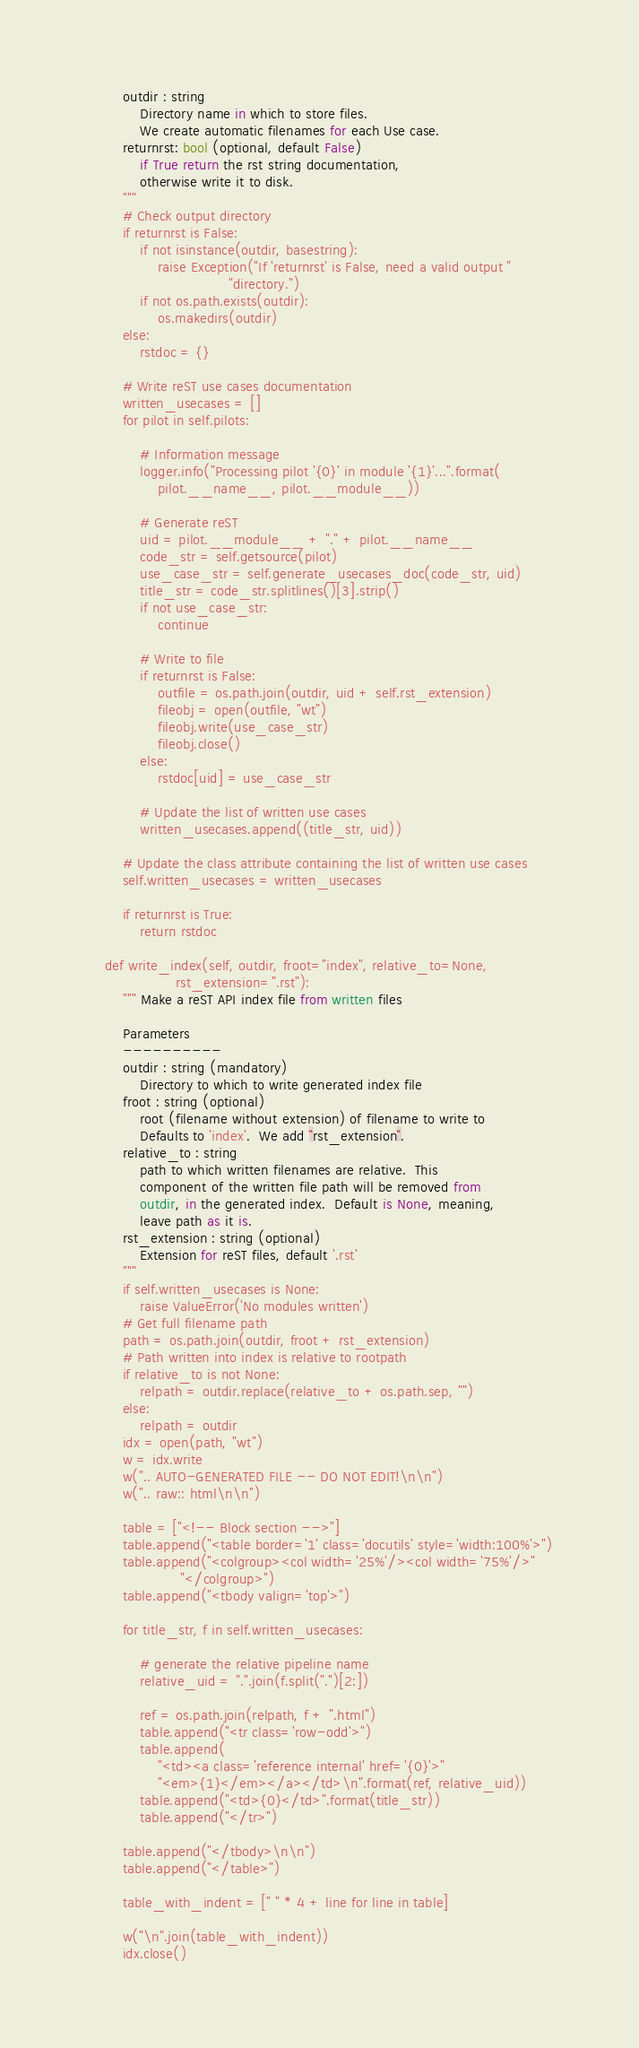<code> <loc_0><loc_0><loc_500><loc_500><_Python_>        outdir : string
            Directory name in which to store files.
            We create automatic filenames for each Use case.
        returnrst: bool (optional, default False)
            if True return the rst string documentation,
            otherwise write it to disk.
        """
        # Check output directory
        if returnrst is False:
            if not isinstance(outdir, basestring):
                raise Exception("If 'returnrst' is False, need a valid output "
                                "directory.")
            if not os.path.exists(outdir):
                os.makedirs(outdir)
        else:
            rstdoc = {}

        # Write reST use cases documentation
        written_usecases = []
        for pilot in self.pilots:

            # Information message
            logger.info("Processing pilot '{0}' in module '{1}'...".format(
                pilot.__name__, pilot.__module__))

            # Generate reST
            uid = pilot.__module__ + "." + pilot.__name__
            code_str = self.getsource(pilot)
            use_case_str = self.generate_usecases_doc(code_str, uid)
            title_str = code_str.splitlines()[3].strip()
            if not use_case_str:
                continue

            # Write to file
            if returnrst is False:
                outfile = os.path.join(outdir, uid + self.rst_extension)
                fileobj = open(outfile, "wt")
                fileobj.write(use_case_str)
                fileobj.close()
            else:
                rstdoc[uid] = use_case_str

            # Update the list of written use cases
            written_usecases.append((title_str, uid))

        # Update the class attribute containing the list of written use cases
        self.written_usecases = written_usecases

        if returnrst is True:
            return rstdoc

    def write_index(self, outdir, froot="index", relative_to=None,
                    rst_extension=".rst"):
        """ Make a reST API index file from written files

        Parameters
        ----------
        outdir : string (mandatory)
            Directory to which to write generated index file
        froot : string (optional)
            root (filename without extension) of filename to write to
            Defaults to 'index'.  We add ``rst_extension``.
        relative_to : string
            path to which written filenames are relative.  This
            component of the written file path will be removed from
            outdir, in the generated index.  Default is None, meaning,
            leave path as it is.
        rst_extension : string (optional)
            Extension for reST files, default '.rst'
        """
        if self.written_usecases is None:
            raise ValueError('No modules written')
        # Get full filename path
        path = os.path.join(outdir, froot + rst_extension)
        # Path written into index is relative to rootpath
        if relative_to is not None:
            relpath = outdir.replace(relative_to + os.path.sep, "")
        else:
            relpath = outdir
        idx = open(path, "wt")
        w = idx.write
        w(".. AUTO-GENERATED FILE -- DO NOT EDIT!\n\n")
        w(".. raw:: html\n\n")

        table = ["<!-- Block section -->"]
        table.append("<table border='1' class='docutils' style='width:100%'>")
        table.append("<colgroup><col width='25%'/><col width='75%'/>"
                     "</colgroup>")
        table.append("<tbody valign='top'>")

        for title_str, f in self.written_usecases:

            # generate the relative pipeline name
            relative_uid = ".".join(f.split(".")[2:])

            ref = os.path.join(relpath, f + ".html")
            table.append("<tr class='row-odd'>")
            table.append(
                "<td><a class='reference internal' href='{0}'>"
                "<em>{1}</em></a></td>\n".format(ref, relative_uid))
            table.append("<td>{0}</td>".format(title_str))
            table.append("</tr>")

        table.append("</tbody>\n\n")
        table.append("</table>")

        table_with_indent = [" " * 4 + line for line in table]

        w("\n".join(table_with_indent))
        idx.close()
</code> 